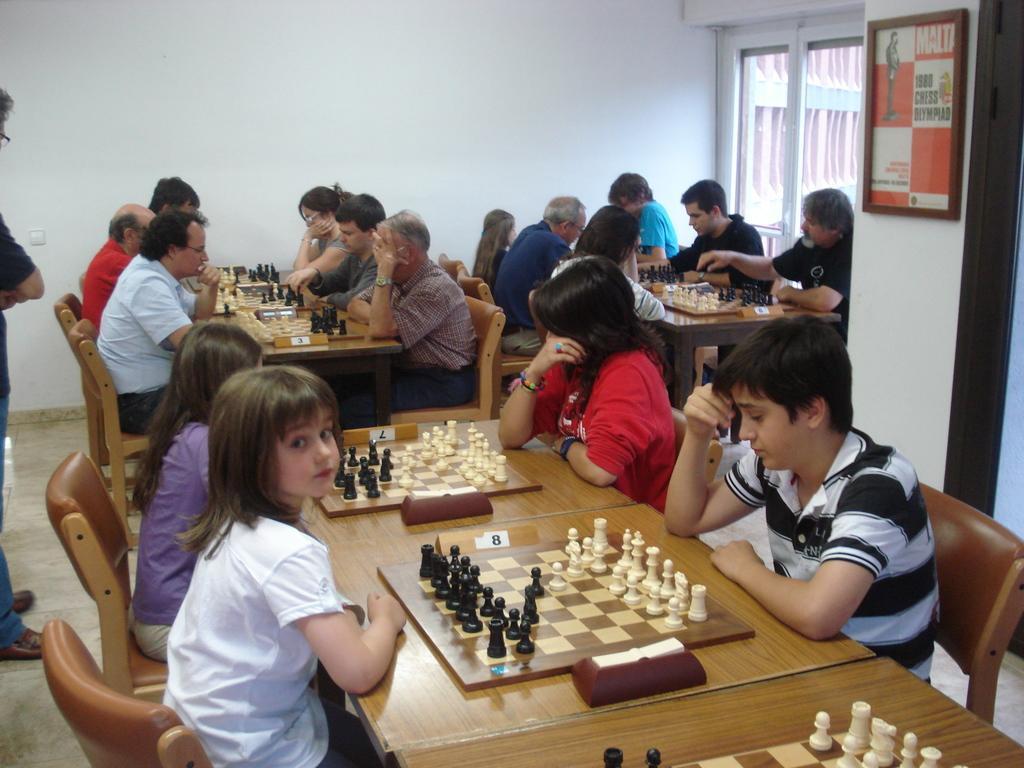In one or two sentences, can you explain what this image depicts? In this image i can see group of people sitting on the chair near to the table and playing chess. And chess board kept on the table. and i can see left side a man stand. And i can see left corner there is a window and i can see right corner there is a frame attached to the wall. i can see a red color shirt women sitting on the chair right side of the image. 